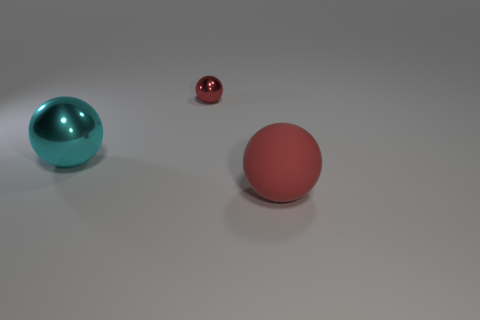What is the shape of the big thing behind the matte sphere?
Provide a short and direct response. Sphere. What is the shape of the large thing that is to the left of the large thing that is in front of the cyan metal object?
Provide a short and direct response. Sphere. Are there any large cyan metallic things that have the same shape as the red shiny thing?
Your answer should be compact. Yes. The cyan thing that is the same size as the red matte thing is what shape?
Keep it short and to the point. Sphere. Is there a cyan metal thing that is on the right side of the red object right of the red object that is behind the large matte thing?
Your answer should be compact. No. Are there any shiny balls of the same size as the red matte ball?
Provide a short and direct response. Yes. There is a thing that is in front of the big cyan shiny object; what size is it?
Your response must be concise. Large. The big thing that is left of the red object in front of the red ball behind the large cyan shiny object is what color?
Your answer should be compact. Cyan. There is a sphere that is on the right side of the red sphere on the left side of the large red rubber ball; what color is it?
Offer a terse response. Red. Is the number of things that are to the right of the big metal sphere greater than the number of matte balls that are in front of the large red sphere?
Ensure brevity in your answer.  Yes. 